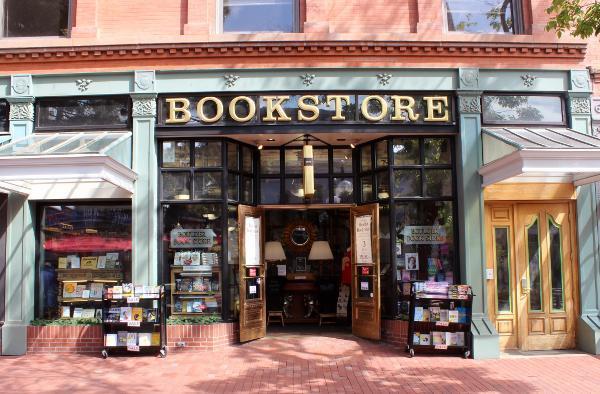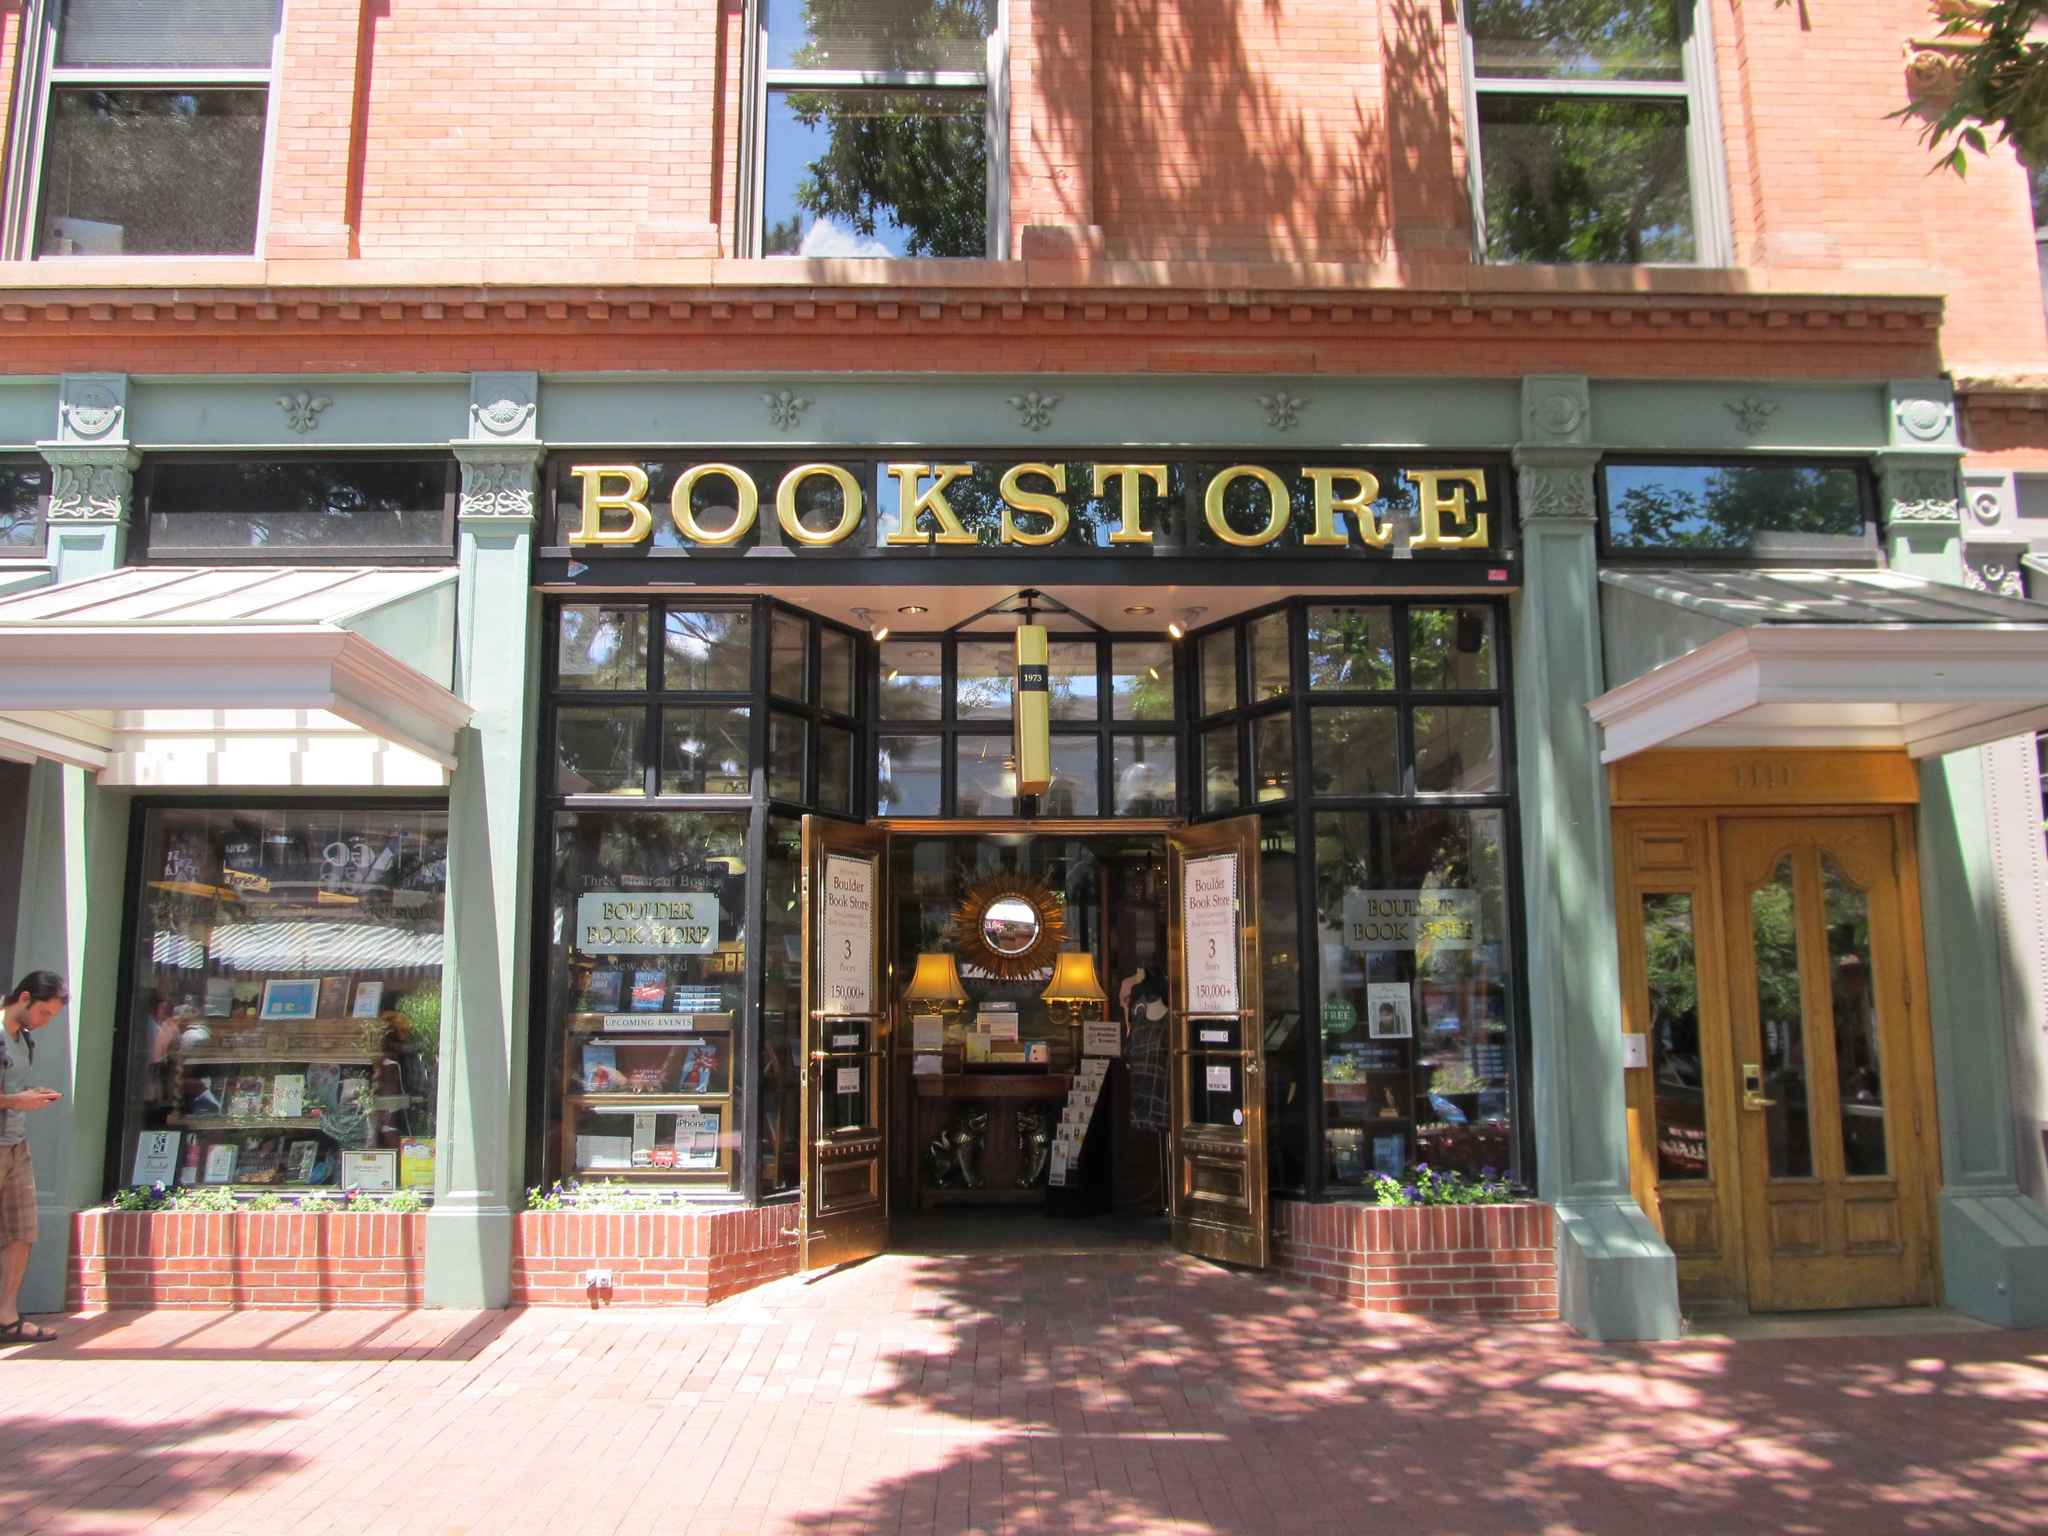The first image is the image on the left, the second image is the image on the right. Considering the images on both sides, is "An image shows at least two people walking past a shop." valid? Answer yes or no. No. 